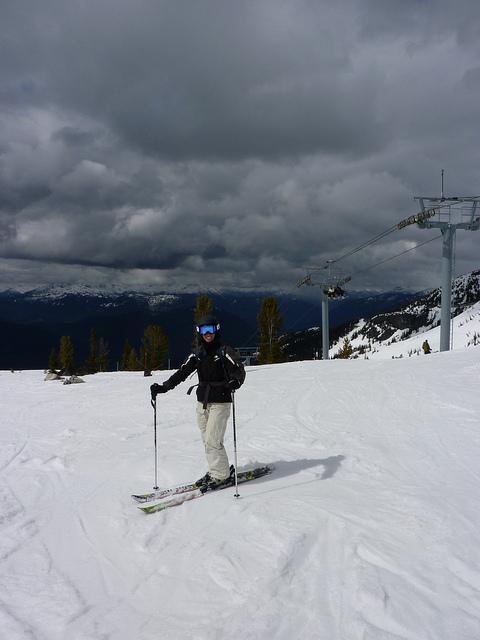How many trains are in front of the building?
Give a very brief answer. 0. 